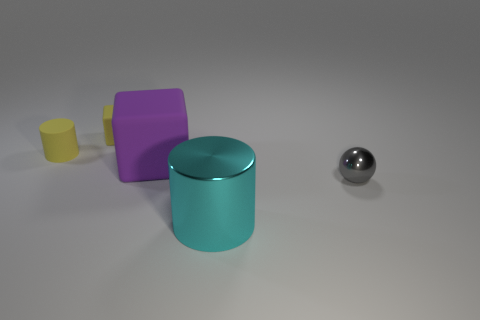There is a thing that is in front of the small yellow matte cylinder and behind the tiny shiny thing; what color is it?
Offer a terse response. Purple. There is a tiny yellow thing that is the same shape as the large purple object; what is it made of?
Offer a very short reply. Rubber. Is the number of tiny gray rubber blocks greater than the number of tiny yellow rubber objects?
Your response must be concise. No. What is the size of the thing that is in front of the large matte thing and behind the big cyan metal cylinder?
Offer a very short reply. Small. There is a purple rubber thing; what shape is it?
Keep it short and to the point. Cube. What number of big matte objects have the same shape as the large cyan metallic object?
Provide a succinct answer. 0. Are there fewer gray shiny objects behind the big purple cube than cylinders that are behind the big cyan cylinder?
Make the answer very short. Yes. There is a large object that is behind the tiny gray metal thing; how many tiny spheres are behind it?
Make the answer very short. 0. Are there any blue matte things?
Offer a very short reply. No. Is there a big cyan object made of the same material as the gray ball?
Your answer should be very brief. Yes. 